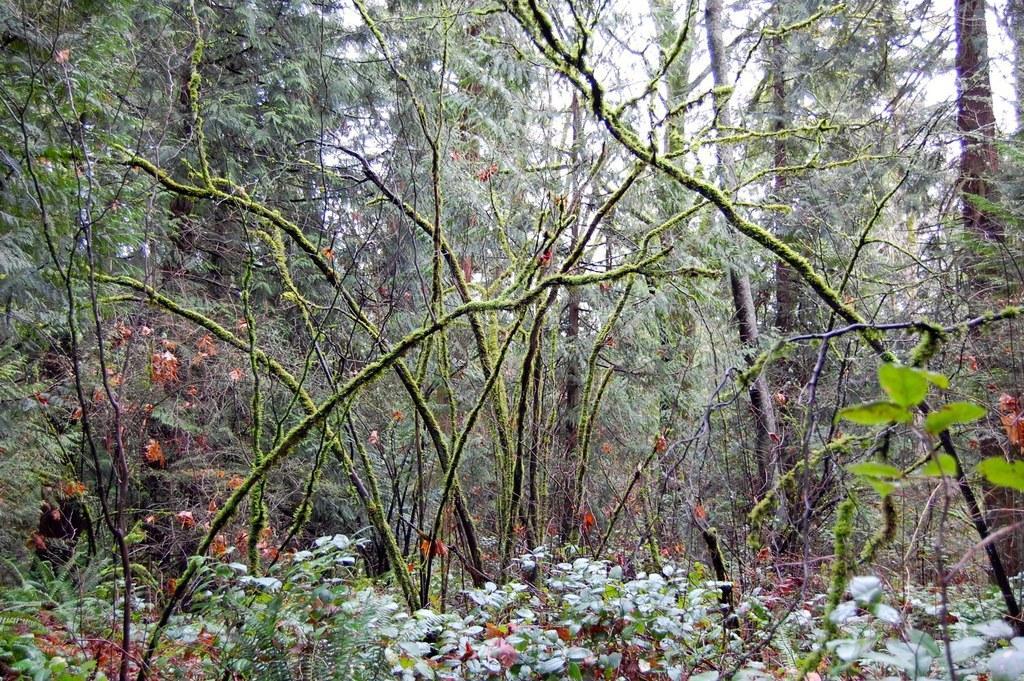Please provide a concise description of this image. In this image we can see trees and plants. 